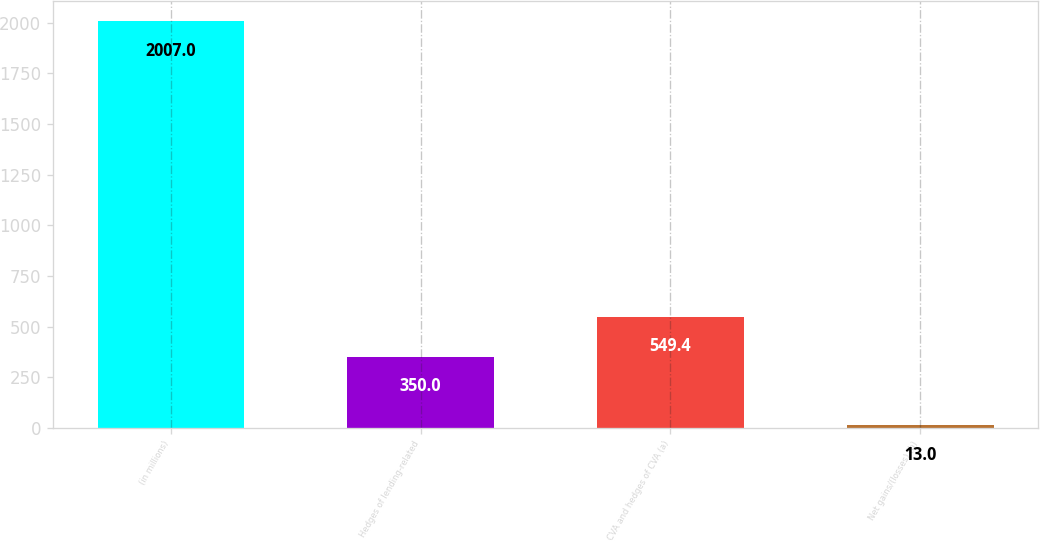Convert chart to OTSL. <chart><loc_0><loc_0><loc_500><loc_500><bar_chart><fcel>(in millions)<fcel>Hedges of lending-related<fcel>CVA and hedges of CVA (a)<fcel>Net gains/(losses) (b)<nl><fcel>2007<fcel>350<fcel>549.4<fcel>13<nl></chart> 